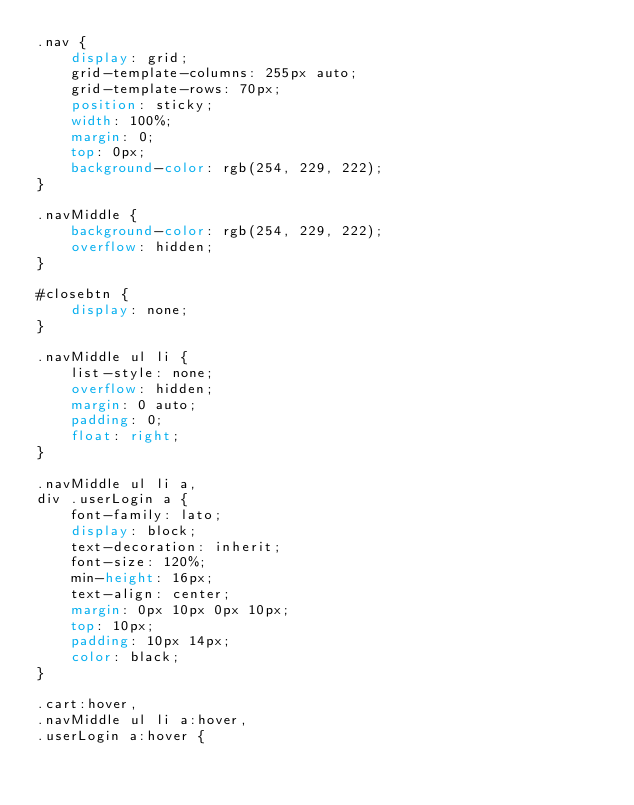Convert code to text. <code><loc_0><loc_0><loc_500><loc_500><_CSS_>.nav {
    display: grid;
    grid-template-columns: 255px auto;
    grid-template-rows: 70px;
    position: sticky;
    width: 100%;
    margin: 0;
    top: 0px;
    background-color: rgb(254, 229, 222);
}

.navMiddle {
    background-color: rgb(254, 229, 222);
    overflow: hidden;
}

#closebtn {
    display: none;
}

.navMiddle ul li {
    list-style: none;
    overflow: hidden;
    margin: 0 auto;
    padding: 0;
    float: right;
}

.navMiddle ul li a,
div .userLogin a {
    font-family: lato;
    display: block;
    text-decoration: inherit;
    font-size: 120%;
    min-height: 16px;
    text-align: center;
    margin: 0px 10px 0px 10px;
    top: 10px;
    padding: 10px 14px;
    color: black;
}

.cart:hover,
.navMiddle ul li a:hover,
.userLogin a:hover {</code> 